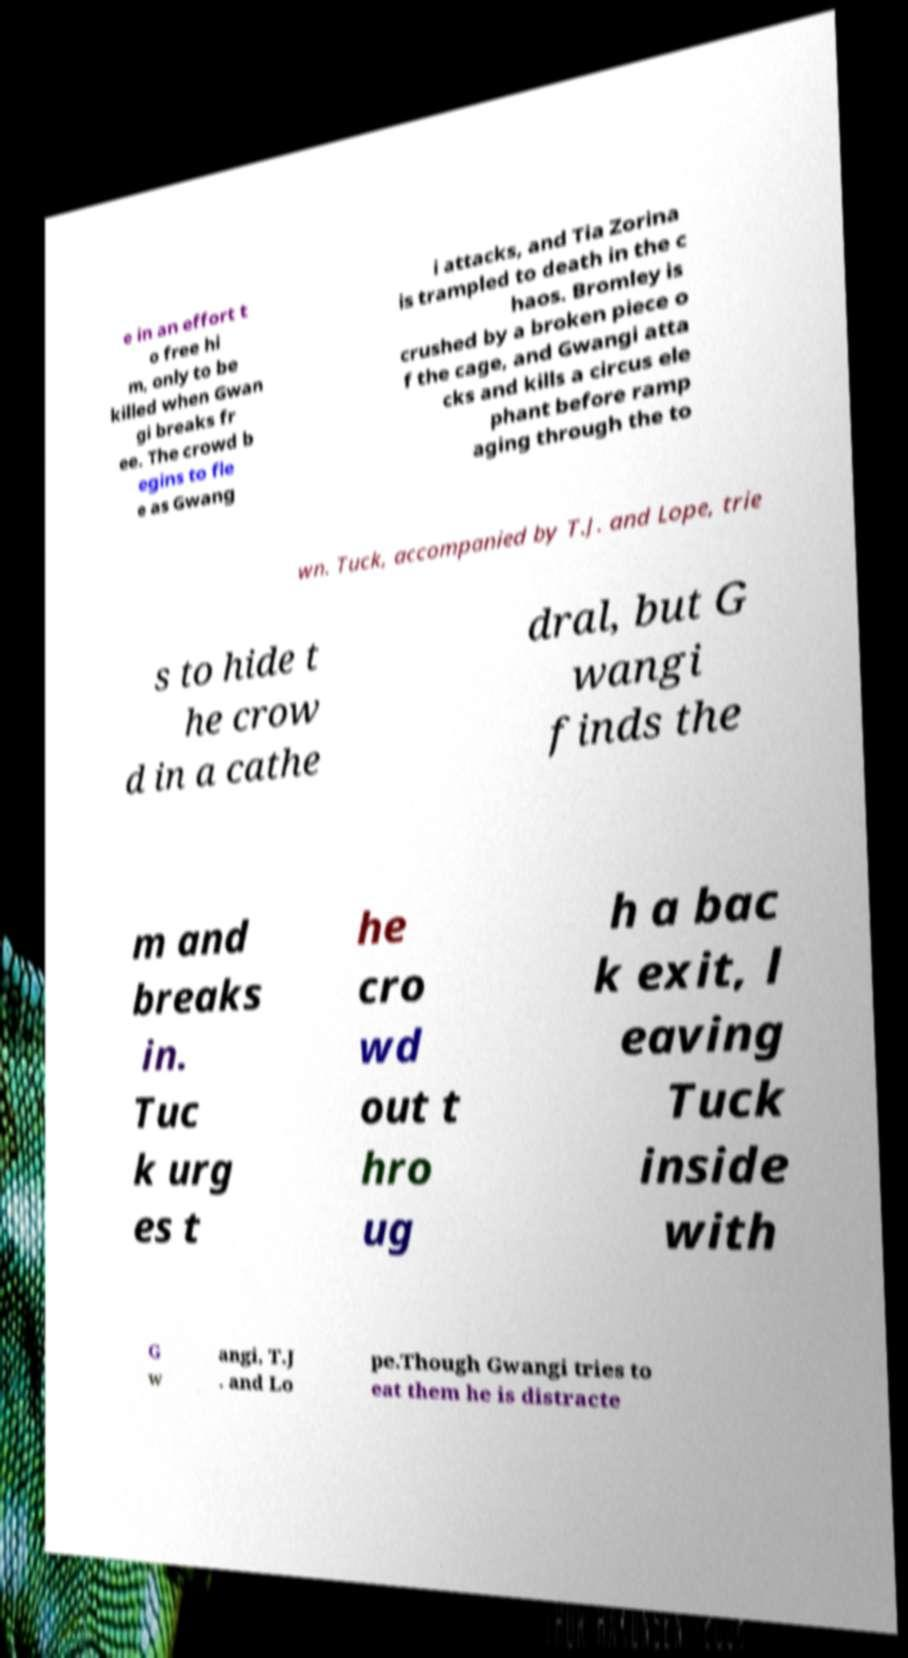Could you assist in decoding the text presented in this image and type it out clearly? e in an effort t o free hi m, only to be killed when Gwan gi breaks fr ee. The crowd b egins to fle e as Gwang i attacks, and Tia Zorina is trampled to death in the c haos. Bromley is crushed by a broken piece o f the cage, and Gwangi atta cks and kills a circus ele phant before ramp aging through the to wn. Tuck, accompanied by T.J. and Lope, trie s to hide t he crow d in a cathe dral, but G wangi finds the m and breaks in. Tuc k urg es t he cro wd out t hro ug h a bac k exit, l eaving Tuck inside with G w angi, T.J . and Lo pe.Though Gwangi tries to eat them he is distracte 